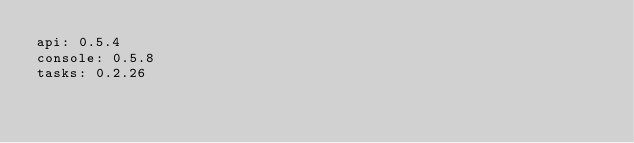Convert code to text. <code><loc_0><loc_0><loc_500><loc_500><_YAML_>api: 0.5.4
console: 0.5.8
tasks: 0.2.26
</code> 